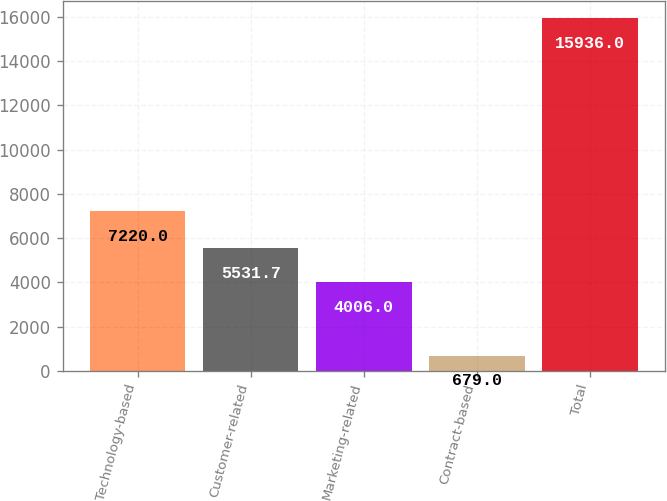<chart> <loc_0><loc_0><loc_500><loc_500><bar_chart><fcel>Technology-based<fcel>Customer-related<fcel>Marketing-related<fcel>Contract-based<fcel>Total<nl><fcel>7220<fcel>5531.7<fcel>4006<fcel>679<fcel>15936<nl></chart> 